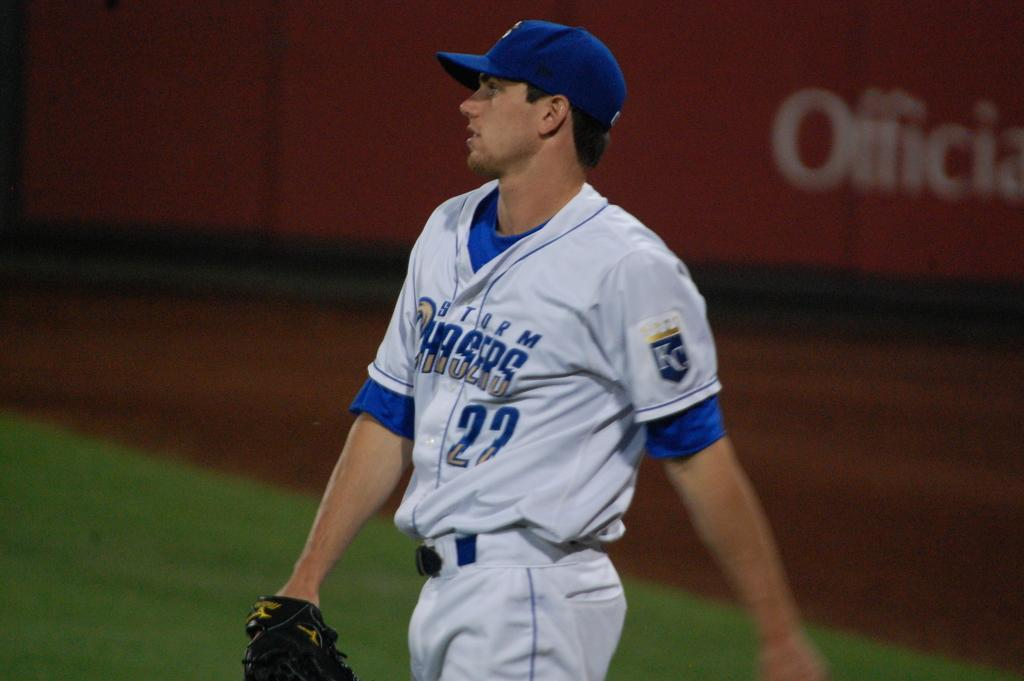<image>
Create a compact narrative representing the image presented. a baseball player for the storm chasers is on the field 